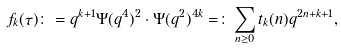<formula> <loc_0><loc_0><loc_500><loc_500>f _ { k } ( \tau ) \colon = q ^ { k + 1 } \Psi ( q ^ { 4 } ) ^ { 2 } \cdot \Psi ( q ^ { 2 } ) ^ { 4 k } = \colon \sum _ { n \geq 0 } t _ { k } ( n ) q ^ { 2 n + k + 1 } ,</formula> 